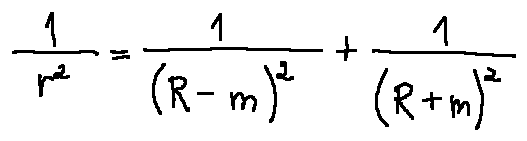<formula> <loc_0><loc_0><loc_500><loc_500>\frac { 1 } { r ^ { 2 } } = \frac { 1 } { ( R - m ) ^ { 2 } } + \frac { 1 } { ( R + m ) ^ { 2 } }</formula> 